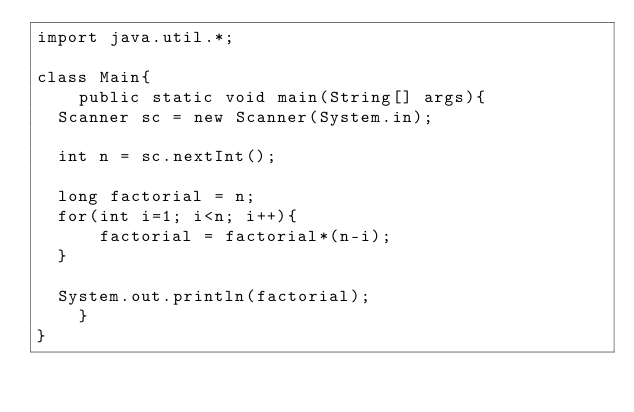<code> <loc_0><loc_0><loc_500><loc_500><_Java_>import java.util.*;

class Main{
    public static void main(String[] args){
	Scanner sc = new Scanner(System.in);

	int n = sc.nextInt();

	long factorial = n;
	for(int i=1; i<n; i++){
	    factorial = factorial*(n-i);
	}

	System.out.println(factorial);
    }
}</code> 